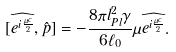Convert formula to latex. <formula><loc_0><loc_0><loc_500><loc_500>[ \widehat { e ^ { i \frac { \mu c } { 2 } } } , \hat { p } ] = - \frac { 8 \pi l _ { P l } ^ { 2 } \gamma } { 6 \ell _ { 0 } } \mu \widehat { e ^ { i \frac { \mu c } { 2 } } } .</formula> 